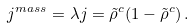Convert formula to latex. <formula><loc_0><loc_0><loc_500><loc_500>j ^ { m a s s } = \lambda j = \tilde { \rho } ^ { c } ( 1 - \tilde { \rho } ^ { c } ) \, .</formula> 